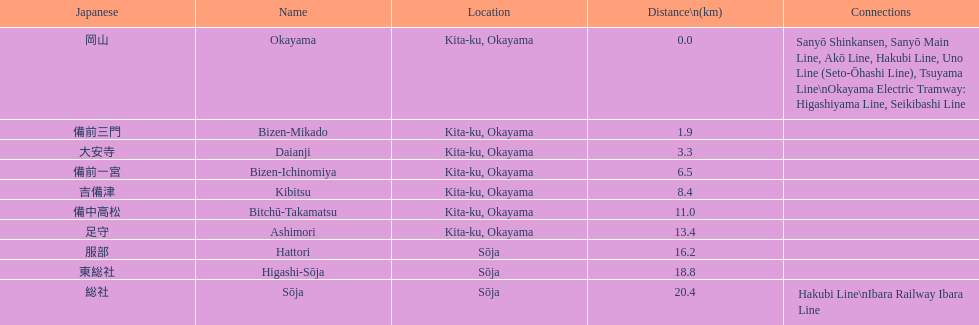Name only the stations that have connections to other lines. Okayama, Sōja. 